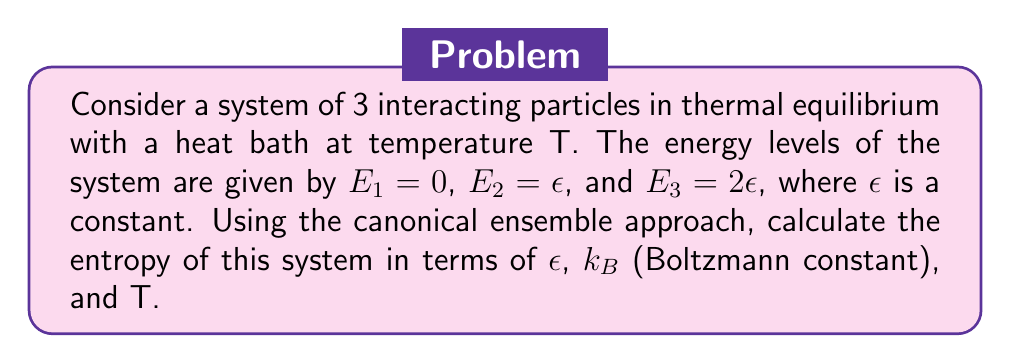Help me with this question. 1. In the canonical ensemble, we start with the partition function Z:

   $$Z = \sum_i e^{-\beta E_i}$$

   where $\beta = \frac{1}{k_B T}$

2. For our system:

   $$Z = e^{-\beta E_1} + e^{-\beta E_2} + e^{-\beta E_3}$$
   $$Z = 1 + e^{-\beta \epsilon} + e^{-2\beta \epsilon}$$

3. The free energy F is given by:

   $$F = -k_B T \ln Z$$

4. The entropy S can be derived from the free energy:

   $$S = -\left(\frac{\partial F}{\partial T}\right)_V$$

5. Expanding this:

   $$S = k_B \ln Z - k_B T \frac{1}{Z} \frac{\partial Z}{\partial T}$$

6. Calculate $\frac{\partial Z}{\partial T}$:

   $$\frac{\partial Z}{\partial T} = \frac{\epsilon}{k_B T^2} e^{-\beta \epsilon} + \frac{2\epsilon}{k_B T^2} e^{-2\beta \epsilon}$$

7. Substitute this back into the entropy equation:

   $$S = k_B \ln(1 + e^{-\beta \epsilon} + e^{-2\beta \epsilon}) + \frac{\epsilon}{T} \frac{e^{-\beta \epsilon} + 2e^{-2\beta \epsilon}}{1 + e^{-\beta \epsilon} + e^{-2\beta \epsilon}}$$

8. This is the final expression for the entropy of the system.
Answer: $S = k_B \ln(1 + e^{-\beta \epsilon} + e^{-2\beta \epsilon}) + \frac{\epsilon}{T} \frac{e^{-\beta \epsilon} + 2e^{-2\beta \epsilon}}{1 + e^{-\beta \epsilon} + e^{-2\beta \epsilon}}$ 